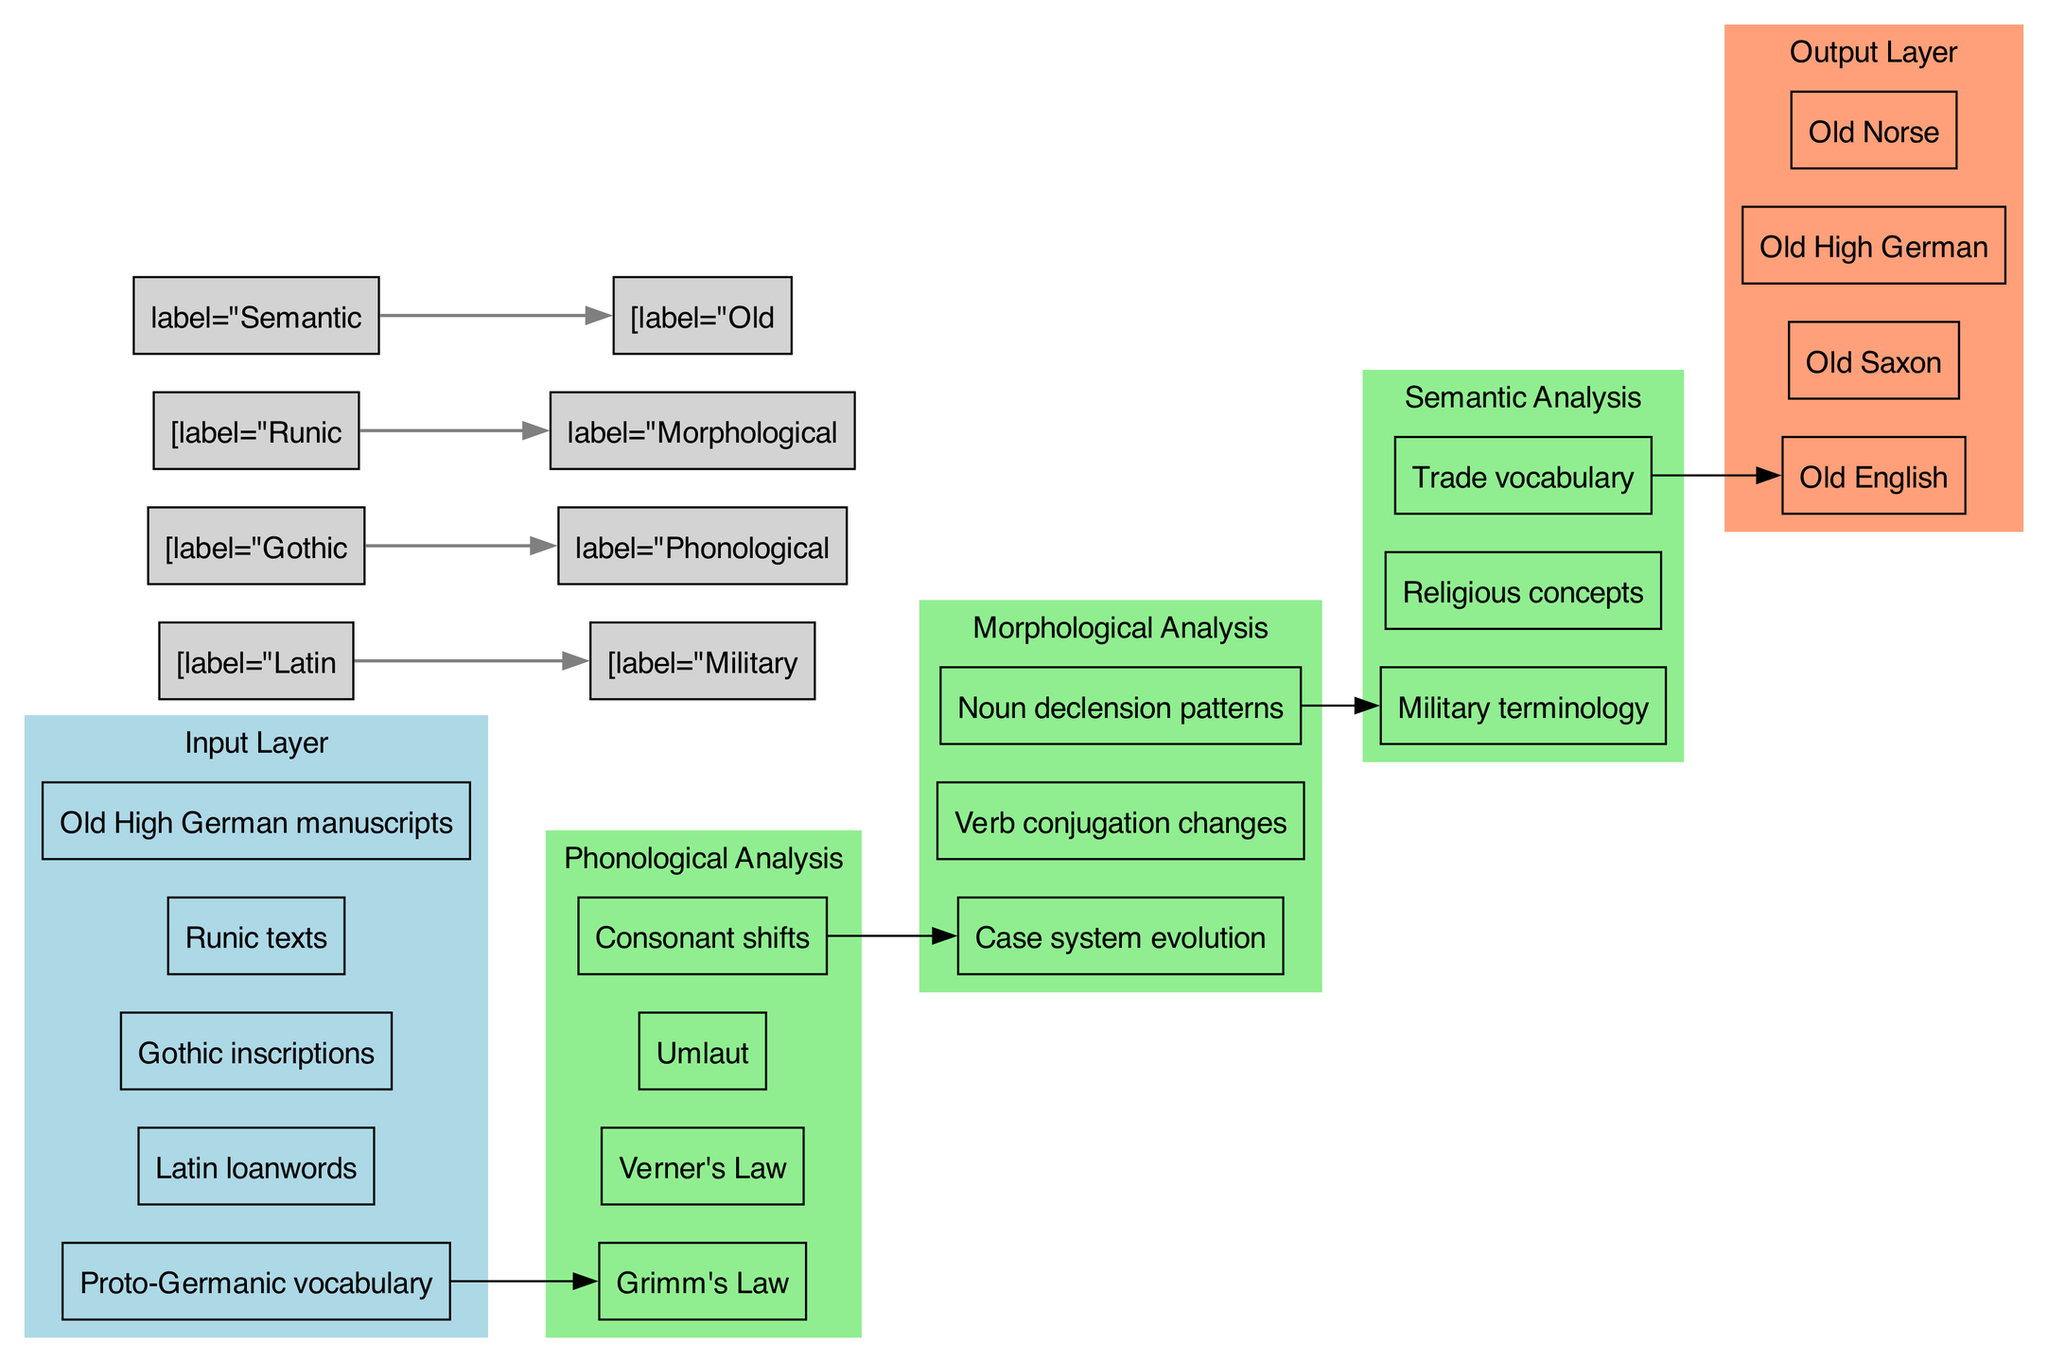What are the nodes in the output layer? The output layer consists of four nodes: Old English, Old Saxon, Old High German, and Old Norse. These can be found in the section labeled 'Output Layer' in the diagram.
Answer: Old English, Old Saxon, Old High German, Old Norse How many nodes are present in the hidden layers? There are a total of 12 nodes in the hidden layers: 4 in the Phonological Analysis layer, 3 in the Morphological Analysis layer, and 3 in the Semantic Analysis layer (4 + 3 + 3 = 10).
Answer: 10 Which node connects Latin loanwords to a hidden layer? Latin loanwords connect to the Military terminology node within the Semantic Analysis hidden layer. This connection is shown with an edge between these two nodes.
Answer: Military terminology What is the relationship between Gothic inscriptions and phonological analysis? Gothic inscriptions are connected to the Phonological Analysis hidden layer, indicating that the data from Gothic inscriptions is analyzed for phonological changes. This is represented by an edge from the Gothic inscriptions node to the corresponding hidden layer node.
Answer: Phonological Analysis Which hidden layer nodes focus on changes in noun and verb structures? The Morphological Analysis layer focuses on changes in noun and verb structures, specifically highlighting the 'Case system evolution', 'Verb conjugation changes', and 'Noun declension patterns' nodes.
Answer: Morphological Analysis What is the primary focus of the hidden layer that includes Grimm's Law? The hidden layer containing Grimm's Law concentrates on phonological changes within the Germanic languages. This is evidenced by the presence of additional phonological rules like Verner's Law and Umlaut in that layer.
Answer: Phonological Analysis How many connections are explicitly defined between the input and output layers? There are three explicit connections defined: from Latin loanwords to Military terminology, Gothic inscriptions to Phonological Analysis, and Runic texts to Morphological Analysis. These connections can be traced by reviewing the edges in the diagram.
Answer: Three Which output layer node is directly influenced by the Semantic Analysis hidden layer? The output layer node Old High German is directly influenced by the Semantic Analysis hidden layer. This direct connection is shown with an edge leading from the Semantic Analysis layer to this specific output node.
Answer: Old High German What is the purpose of the diagram? The diagram serves to visualize the neural network analyzing the linguistic evolution of Germanic languages in relation to Latin influences, showcasing the flow of data from inputs through hidden analyses to outputs.
Answer: Visualize linguistic evolution 